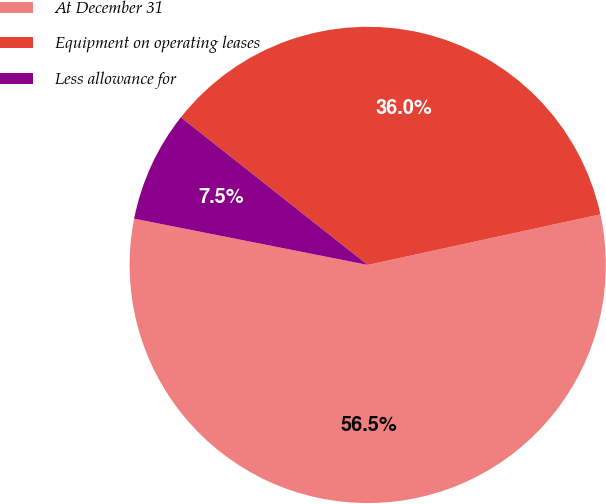<chart> <loc_0><loc_0><loc_500><loc_500><pie_chart><fcel>At December 31<fcel>Equipment on operating leases<fcel>Less allowance for<nl><fcel>56.52%<fcel>35.95%<fcel>7.53%<nl></chart> 